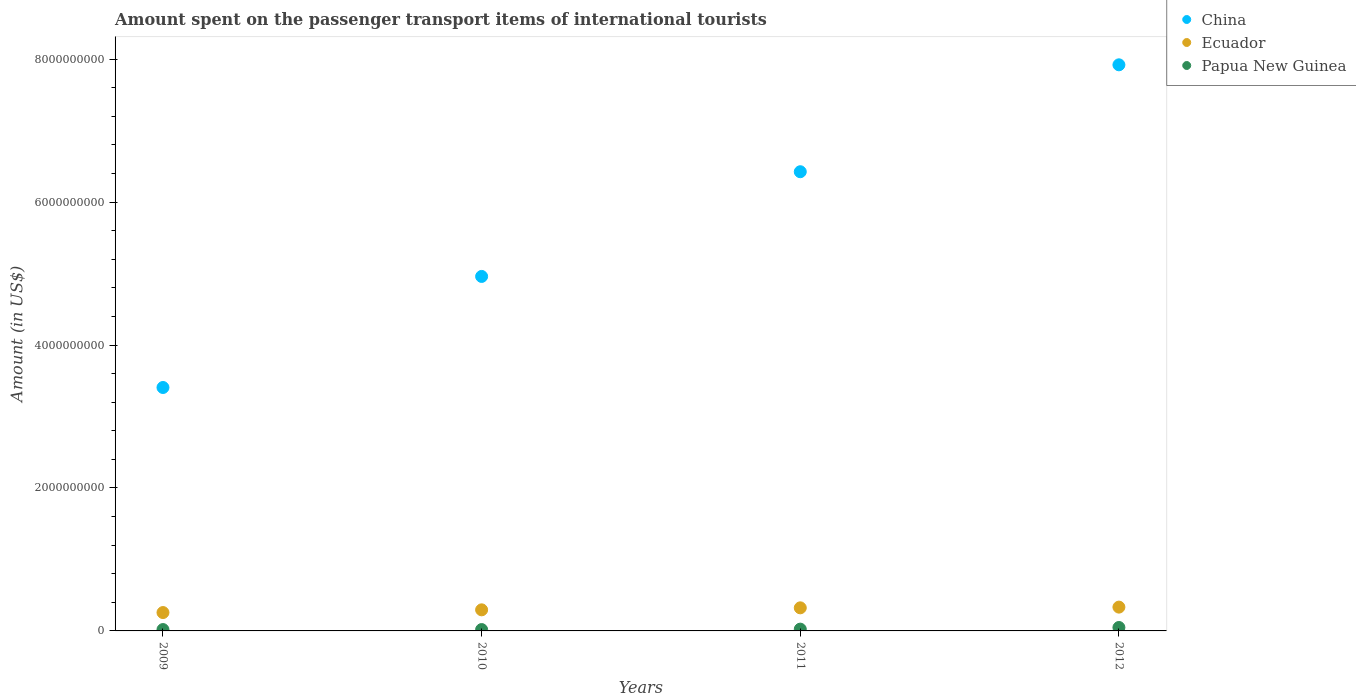How many different coloured dotlines are there?
Offer a terse response. 3. Is the number of dotlines equal to the number of legend labels?
Provide a short and direct response. Yes. What is the amount spent on the passenger transport items of international tourists in China in 2012?
Ensure brevity in your answer.  7.92e+09. Across all years, what is the maximum amount spent on the passenger transport items of international tourists in China?
Keep it short and to the point. 7.92e+09. Across all years, what is the minimum amount spent on the passenger transport items of international tourists in China?
Your response must be concise. 3.41e+09. In which year was the amount spent on the passenger transport items of international tourists in China maximum?
Provide a short and direct response. 2012. In which year was the amount spent on the passenger transport items of international tourists in Papua New Guinea minimum?
Ensure brevity in your answer.  2009. What is the total amount spent on the passenger transport items of international tourists in Papua New Guinea in the graph?
Make the answer very short. 1.11e+08. What is the difference between the amount spent on the passenger transport items of international tourists in Papua New Guinea in 2009 and that in 2012?
Provide a short and direct response. -2.90e+07. What is the difference between the amount spent on the passenger transport items of international tourists in Ecuador in 2012 and the amount spent on the passenger transport items of international tourists in China in 2010?
Keep it short and to the point. -4.63e+09. What is the average amount spent on the passenger transport items of international tourists in China per year?
Your answer should be very brief. 5.68e+09. In the year 2011, what is the difference between the amount spent on the passenger transport items of international tourists in Papua New Guinea and amount spent on the passenger transport items of international tourists in China?
Your answer should be compact. -6.40e+09. What is the ratio of the amount spent on the passenger transport items of international tourists in Papua New Guinea in 2010 to that in 2012?
Make the answer very short. 0.4. What is the difference between the highest and the second highest amount spent on the passenger transport items of international tourists in Papua New Guinea?
Your answer should be very brief. 2.30e+07. What is the difference between the highest and the lowest amount spent on the passenger transport items of international tourists in Papua New Guinea?
Give a very brief answer. 2.90e+07. Is the sum of the amount spent on the passenger transport items of international tourists in Ecuador in 2010 and 2012 greater than the maximum amount spent on the passenger transport items of international tourists in China across all years?
Offer a very short reply. No. Is it the case that in every year, the sum of the amount spent on the passenger transport items of international tourists in China and amount spent on the passenger transport items of international tourists in Ecuador  is greater than the amount spent on the passenger transport items of international tourists in Papua New Guinea?
Make the answer very short. Yes. Does the amount spent on the passenger transport items of international tourists in Ecuador monotonically increase over the years?
Your answer should be compact. Yes. Is the amount spent on the passenger transport items of international tourists in China strictly less than the amount spent on the passenger transport items of international tourists in Ecuador over the years?
Provide a succinct answer. No. How many dotlines are there?
Offer a very short reply. 3. What is the difference between two consecutive major ticks on the Y-axis?
Provide a short and direct response. 2.00e+09. Does the graph contain grids?
Your answer should be compact. No. What is the title of the graph?
Offer a terse response. Amount spent on the passenger transport items of international tourists. What is the label or title of the Y-axis?
Provide a short and direct response. Amount (in US$). What is the Amount (in US$) in China in 2009?
Ensure brevity in your answer.  3.41e+09. What is the Amount (in US$) in Ecuador in 2009?
Provide a short and direct response. 2.57e+08. What is the Amount (in US$) in Papua New Guinea in 2009?
Your answer should be compact. 1.90e+07. What is the Amount (in US$) of China in 2010?
Provide a short and direct response. 4.96e+09. What is the Amount (in US$) of Ecuador in 2010?
Offer a very short reply. 2.95e+08. What is the Amount (in US$) of Papua New Guinea in 2010?
Your response must be concise. 1.90e+07. What is the Amount (in US$) in China in 2011?
Offer a terse response. 6.42e+09. What is the Amount (in US$) of Ecuador in 2011?
Make the answer very short. 3.23e+08. What is the Amount (in US$) in Papua New Guinea in 2011?
Ensure brevity in your answer.  2.50e+07. What is the Amount (in US$) of China in 2012?
Provide a succinct answer. 7.92e+09. What is the Amount (in US$) of Ecuador in 2012?
Keep it short and to the point. 3.33e+08. What is the Amount (in US$) of Papua New Guinea in 2012?
Give a very brief answer. 4.80e+07. Across all years, what is the maximum Amount (in US$) in China?
Provide a succinct answer. 7.92e+09. Across all years, what is the maximum Amount (in US$) in Ecuador?
Offer a terse response. 3.33e+08. Across all years, what is the maximum Amount (in US$) in Papua New Guinea?
Keep it short and to the point. 4.80e+07. Across all years, what is the minimum Amount (in US$) in China?
Make the answer very short. 3.41e+09. Across all years, what is the minimum Amount (in US$) in Ecuador?
Make the answer very short. 2.57e+08. Across all years, what is the minimum Amount (in US$) of Papua New Guinea?
Provide a succinct answer. 1.90e+07. What is the total Amount (in US$) in China in the graph?
Provide a succinct answer. 2.27e+1. What is the total Amount (in US$) of Ecuador in the graph?
Give a very brief answer. 1.21e+09. What is the total Amount (in US$) of Papua New Guinea in the graph?
Keep it short and to the point. 1.11e+08. What is the difference between the Amount (in US$) of China in 2009 and that in 2010?
Offer a terse response. -1.55e+09. What is the difference between the Amount (in US$) in Ecuador in 2009 and that in 2010?
Your response must be concise. -3.80e+07. What is the difference between the Amount (in US$) in Papua New Guinea in 2009 and that in 2010?
Make the answer very short. 0. What is the difference between the Amount (in US$) in China in 2009 and that in 2011?
Give a very brief answer. -3.02e+09. What is the difference between the Amount (in US$) of Ecuador in 2009 and that in 2011?
Your response must be concise. -6.60e+07. What is the difference between the Amount (in US$) of Papua New Guinea in 2009 and that in 2011?
Provide a succinct answer. -6.00e+06. What is the difference between the Amount (in US$) in China in 2009 and that in 2012?
Offer a very short reply. -4.52e+09. What is the difference between the Amount (in US$) in Ecuador in 2009 and that in 2012?
Your answer should be compact. -7.60e+07. What is the difference between the Amount (in US$) in Papua New Guinea in 2009 and that in 2012?
Provide a succinct answer. -2.90e+07. What is the difference between the Amount (in US$) in China in 2010 and that in 2011?
Provide a succinct answer. -1.46e+09. What is the difference between the Amount (in US$) of Ecuador in 2010 and that in 2011?
Give a very brief answer. -2.80e+07. What is the difference between the Amount (in US$) of Papua New Guinea in 2010 and that in 2011?
Keep it short and to the point. -6.00e+06. What is the difference between the Amount (in US$) in China in 2010 and that in 2012?
Make the answer very short. -2.96e+09. What is the difference between the Amount (in US$) in Ecuador in 2010 and that in 2012?
Your answer should be very brief. -3.80e+07. What is the difference between the Amount (in US$) of Papua New Guinea in 2010 and that in 2012?
Keep it short and to the point. -2.90e+07. What is the difference between the Amount (in US$) in China in 2011 and that in 2012?
Keep it short and to the point. -1.50e+09. What is the difference between the Amount (in US$) of Ecuador in 2011 and that in 2012?
Make the answer very short. -1.00e+07. What is the difference between the Amount (in US$) of Papua New Guinea in 2011 and that in 2012?
Ensure brevity in your answer.  -2.30e+07. What is the difference between the Amount (in US$) of China in 2009 and the Amount (in US$) of Ecuador in 2010?
Give a very brief answer. 3.11e+09. What is the difference between the Amount (in US$) in China in 2009 and the Amount (in US$) in Papua New Guinea in 2010?
Make the answer very short. 3.39e+09. What is the difference between the Amount (in US$) of Ecuador in 2009 and the Amount (in US$) of Papua New Guinea in 2010?
Give a very brief answer. 2.38e+08. What is the difference between the Amount (in US$) in China in 2009 and the Amount (in US$) in Ecuador in 2011?
Provide a short and direct response. 3.08e+09. What is the difference between the Amount (in US$) in China in 2009 and the Amount (in US$) in Papua New Guinea in 2011?
Your answer should be very brief. 3.38e+09. What is the difference between the Amount (in US$) in Ecuador in 2009 and the Amount (in US$) in Papua New Guinea in 2011?
Keep it short and to the point. 2.32e+08. What is the difference between the Amount (in US$) in China in 2009 and the Amount (in US$) in Ecuador in 2012?
Provide a succinct answer. 3.07e+09. What is the difference between the Amount (in US$) of China in 2009 and the Amount (in US$) of Papua New Guinea in 2012?
Provide a short and direct response. 3.36e+09. What is the difference between the Amount (in US$) of Ecuador in 2009 and the Amount (in US$) of Papua New Guinea in 2012?
Keep it short and to the point. 2.09e+08. What is the difference between the Amount (in US$) of China in 2010 and the Amount (in US$) of Ecuador in 2011?
Offer a terse response. 4.64e+09. What is the difference between the Amount (in US$) of China in 2010 and the Amount (in US$) of Papua New Guinea in 2011?
Your answer should be compact. 4.94e+09. What is the difference between the Amount (in US$) in Ecuador in 2010 and the Amount (in US$) in Papua New Guinea in 2011?
Ensure brevity in your answer.  2.70e+08. What is the difference between the Amount (in US$) in China in 2010 and the Amount (in US$) in Ecuador in 2012?
Keep it short and to the point. 4.63e+09. What is the difference between the Amount (in US$) of China in 2010 and the Amount (in US$) of Papua New Guinea in 2012?
Make the answer very short. 4.91e+09. What is the difference between the Amount (in US$) in Ecuador in 2010 and the Amount (in US$) in Papua New Guinea in 2012?
Ensure brevity in your answer.  2.47e+08. What is the difference between the Amount (in US$) in China in 2011 and the Amount (in US$) in Ecuador in 2012?
Offer a very short reply. 6.09e+09. What is the difference between the Amount (in US$) in China in 2011 and the Amount (in US$) in Papua New Guinea in 2012?
Provide a short and direct response. 6.38e+09. What is the difference between the Amount (in US$) in Ecuador in 2011 and the Amount (in US$) in Papua New Guinea in 2012?
Provide a short and direct response. 2.75e+08. What is the average Amount (in US$) of China per year?
Your answer should be compact. 5.68e+09. What is the average Amount (in US$) of Ecuador per year?
Your answer should be very brief. 3.02e+08. What is the average Amount (in US$) of Papua New Guinea per year?
Ensure brevity in your answer.  2.78e+07. In the year 2009, what is the difference between the Amount (in US$) in China and Amount (in US$) in Ecuador?
Your response must be concise. 3.15e+09. In the year 2009, what is the difference between the Amount (in US$) in China and Amount (in US$) in Papua New Guinea?
Offer a very short reply. 3.39e+09. In the year 2009, what is the difference between the Amount (in US$) in Ecuador and Amount (in US$) in Papua New Guinea?
Provide a short and direct response. 2.38e+08. In the year 2010, what is the difference between the Amount (in US$) in China and Amount (in US$) in Ecuador?
Offer a terse response. 4.66e+09. In the year 2010, what is the difference between the Amount (in US$) in China and Amount (in US$) in Papua New Guinea?
Provide a succinct answer. 4.94e+09. In the year 2010, what is the difference between the Amount (in US$) of Ecuador and Amount (in US$) of Papua New Guinea?
Offer a terse response. 2.76e+08. In the year 2011, what is the difference between the Amount (in US$) in China and Amount (in US$) in Ecuador?
Ensure brevity in your answer.  6.10e+09. In the year 2011, what is the difference between the Amount (in US$) in China and Amount (in US$) in Papua New Guinea?
Your answer should be very brief. 6.40e+09. In the year 2011, what is the difference between the Amount (in US$) in Ecuador and Amount (in US$) in Papua New Guinea?
Make the answer very short. 2.98e+08. In the year 2012, what is the difference between the Amount (in US$) of China and Amount (in US$) of Ecuador?
Your response must be concise. 7.59e+09. In the year 2012, what is the difference between the Amount (in US$) in China and Amount (in US$) in Papua New Guinea?
Provide a short and direct response. 7.87e+09. In the year 2012, what is the difference between the Amount (in US$) of Ecuador and Amount (in US$) of Papua New Guinea?
Offer a very short reply. 2.85e+08. What is the ratio of the Amount (in US$) of China in 2009 to that in 2010?
Provide a short and direct response. 0.69. What is the ratio of the Amount (in US$) in Ecuador in 2009 to that in 2010?
Offer a terse response. 0.87. What is the ratio of the Amount (in US$) of China in 2009 to that in 2011?
Provide a succinct answer. 0.53. What is the ratio of the Amount (in US$) of Ecuador in 2009 to that in 2011?
Make the answer very short. 0.8. What is the ratio of the Amount (in US$) of Papua New Guinea in 2009 to that in 2011?
Provide a short and direct response. 0.76. What is the ratio of the Amount (in US$) in China in 2009 to that in 2012?
Provide a short and direct response. 0.43. What is the ratio of the Amount (in US$) of Ecuador in 2009 to that in 2012?
Provide a succinct answer. 0.77. What is the ratio of the Amount (in US$) of Papua New Guinea in 2009 to that in 2012?
Offer a terse response. 0.4. What is the ratio of the Amount (in US$) of China in 2010 to that in 2011?
Provide a succinct answer. 0.77. What is the ratio of the Amount (in US$) of Ecuador in 2010 to that in 2011?
Ensure brevity in your answer.  0.91. What is the ratio of the Amount (in US$) in Papua New Guinea in 2010 to that in 2011?
Offer a very short reply. 0.76. What is the ratio of the Amount (in US$) in China in 2010 to that in 2012?
Offer a terse response. 0.63. What is the ratio of the Amount (in US$) in Ecuador in 2010 to that in 2012?
Give a very brief answer. 0.89. What is the ratio of the Amount (in US$) of Papua New Guinea in 2010 to that in 2012?
Your answer should be compact. 0.4. What is the ratio of the Amount (in US$) in China in 2011 to that in 2012?
Offer a very short reply. 0.81. What is the ratio of the Amount (in US$) in Papua New Guinea in 2011 to that in 2012?
Offer a terse response. 0.52. What is the difference between the highest and the second highest Amount (in US$) of China?
Give a very brief answer. 1.50e+09. What is the difference between the highest and the second highest Amount (in US$) of Papua New Guinea?
Offer a terse response. 2.30e+07. What is the difference between the highest and the lowest Amount (in US$) in China?
Provide a short and direct response. 4.52e+09. What is the difference between the highest and the lowest Amount (in US$) in Ecuador?
Your answer should be very brief. 7.60e+07. What is the difference between the highest and the lowest Amount (in US$) in Papua New Guinea?
Keep it short and to the point. 2.90e+07. 